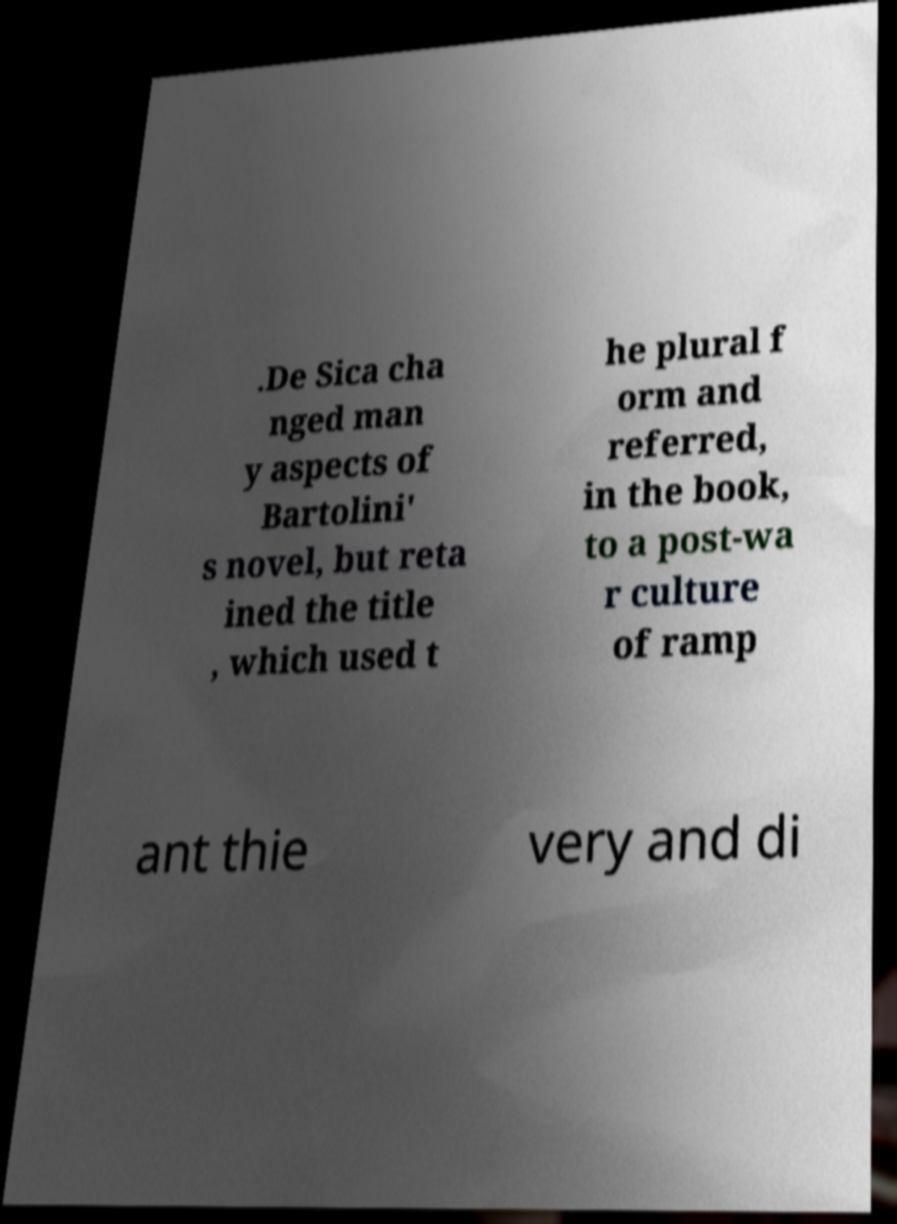Please read and relay the text visible in this image. What does it say? .De Sica cha nged man y aspects of Bartolini' s novel, but reta ined the title , which used t he plural f orm and referred, in the book, to a post-wa r culture of ramp ant thie very and di 